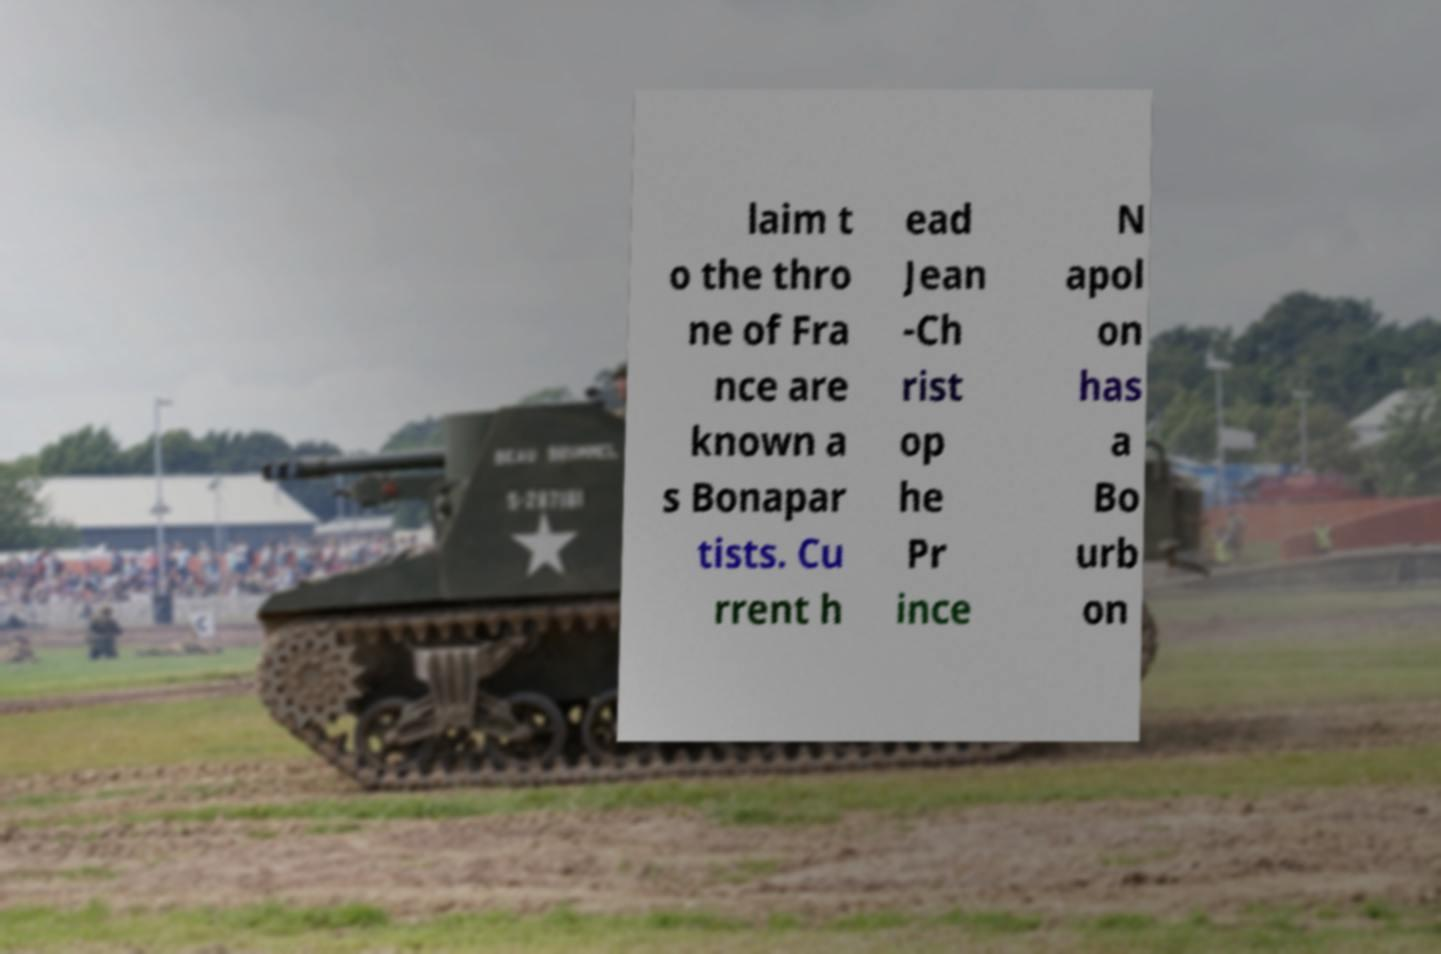Could you assist in decoding the text presented in this image and type it out clearly? laim t o the thro ne of Fra nce are known a s Bonapar tists. Cu rrent h ead Jean -Ch rist op he Pr ince N apol on has a Bo urb on 